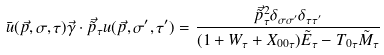<formula> <loc_0><loc_0><loc_500><loc_500>\bar { u } ( \vec { p } , \sigma , \tau ) \vec { \gamma } \cdot \vec { \tilde { p } } _ { \tau } u ( \vec { p } , \sigma ^ { \prime } , \tau ^ { \prime } ) = \frac { \vec { \tilde { p } } _ { \tau } ^ { 2 } \delta _ { \sigma \sigma ^ { \prime } } \delta _ { \tau \tau ^ { \prime } } } { ( 1 + W _ { \tau } + X _ { 0 0 \tau } ) \tilde { E } _ { \tau } - T _ { 0 \tau } \tilde { M } _ { \tau } }</formula> 